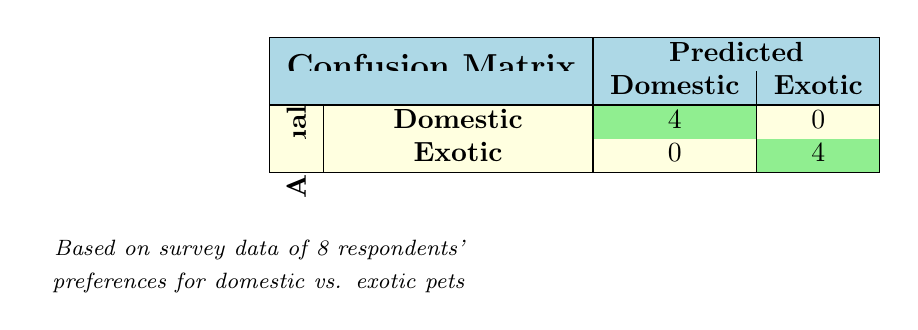What is the total number of respondents who preferred domestic pets? From the table, there are four respondents who preferred domestic pets, as indicated in the "Actual" row under "Domestic."
Answer: 4 What is the number of respondents who preferred exotic pets? The table shows that there are four respondents who preferred exotic pets, as indicated in the "Actual" row under "Exotic."
Answer: 4 How many respondents had a positive adoption experience? The table indicates that four respondents (Alice, Catherine, Evelyn, and Grace) preferred domestic pets and reported a positive adoption experience. Since there are no respondents with a positive experience for exotic pets, the total is four.
Answer: 4 Is it true that all respondents who preferred exotic pets experienced negative adoption experiences? The table indicates that two respondents (David and Henry) who preferred exotic pets had negative experiences, while two others (Bob and Frank) had mixed experiences. Therefore, it is false that all respondents had negative experiences.
Answer: No How many respondents experienced mixed adoption experiences? Looking at the table, there are two respondents (Bob and Frank) with mixed adoption experiences, both of whom preferred exotic pets.
Answer: 2 What is the perceived risk level for the domestic pet preference group? All respondents who preferred domestic pets reported a perceived risk level of "Low," as shown in their individual data.
Answer: Low If we assume equal weightage for all factors in the survey, what is the average perceived risk level for all respondents? The perceived risks are as follows: Low (4 respondents) and Medium (2 respondents) plus High (2 respondents). To compute the average risk: Risk level Low = 1, Medium = 2, High = 3. Thus, [(4*1 + 2*2 + 2*3) / 8] = (4 + 4 + 6) / 8 = 14 / 8 = 1.75, which we can round to Low-Medium.
Answer: Low-Medium What is the environmental impact classification for respondents who preferred exotic pets? According to the table, both respondents who preferred exotic pets reported a "High" environmental impact.
Answer: High Is it correct to say that all domestic pet respondents had high ease of care? The table shows that all respondents who preferred domestic pets reported a "High" ease of care, so it is true.
Answer: Yes 